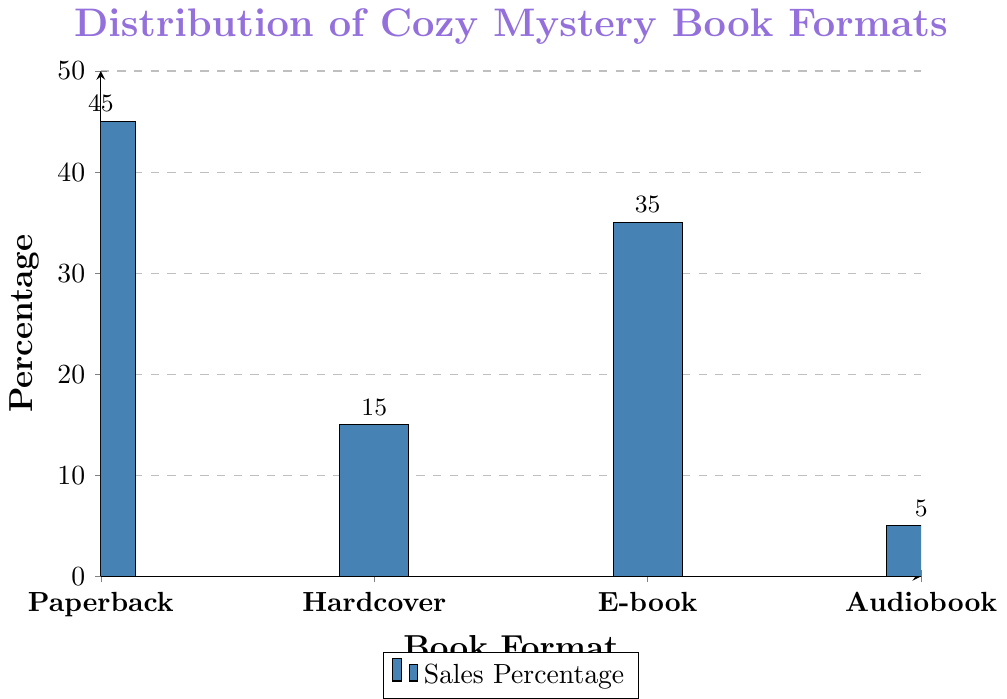Which book format has the highest percentage of sales? By looking at the heights of the bars, we can see that the bar representing the Paperback format is the tallest.
Answer: Paperback Which book format has the lowest percentage of sales? By observing the heights of the bars, we can determine that the Audiobook format has the shortest bar.
Answer: Audiobook What is the combined percentage of sales for Paperback and E-book formats? To find the combined percentage, add the percentages for Paperback and E-book formats: 45 + 35 = 80.
Answer: 80 How much higher is the percentage of sales for Paperback compared to Hardcover? To determine the difference in percentages, subtract the percentage of Hardcover from Paperback: 45 - 15 = 30.
Answer: 30 Which format has a higher sales percentage: Hardcover or E-book? By comparing the heights of the bars for Hardcover and E-book, we see that the E-book bar is higher.
Answer: E-book What is the difference in sales percentage between the most sold format and the least sold format? Subtract the percentage of the least sold format (Audiobook) from the most sold format (Paperback): 45 - 5 = 40.
Answer: 40 What percentage of sales do non-paperback formats contribute to in total? Add the percentages of all formats except Paperback: 15 (Hardcover) + 35 (E-book) + 5 (Audiobook) = 55.
Answer: 55 If you combine the percentages of Hardcover and Audiobook, does it surpass the percentage of E-book sales? Sum the percentages of Hardcover and Audiobook: 15 + 5 = 20. Since 20 is less than 35, it does not surpass the E-book percentage.
Answer: No What is the average percentage of sales across all book formats? To find the average, sum all the percentages and divide by the number of formats: (45 + 15 + 35 + 5) / 4 = 100 / 4 = 25.
Answer: 25 By what factor is the percentage of Paperback sales greater than that of Audiobook sales? Divide the percentage of Paperback sales by the percentage of Audiobook sales: 45 / 5 = 9.
Answer: 9 